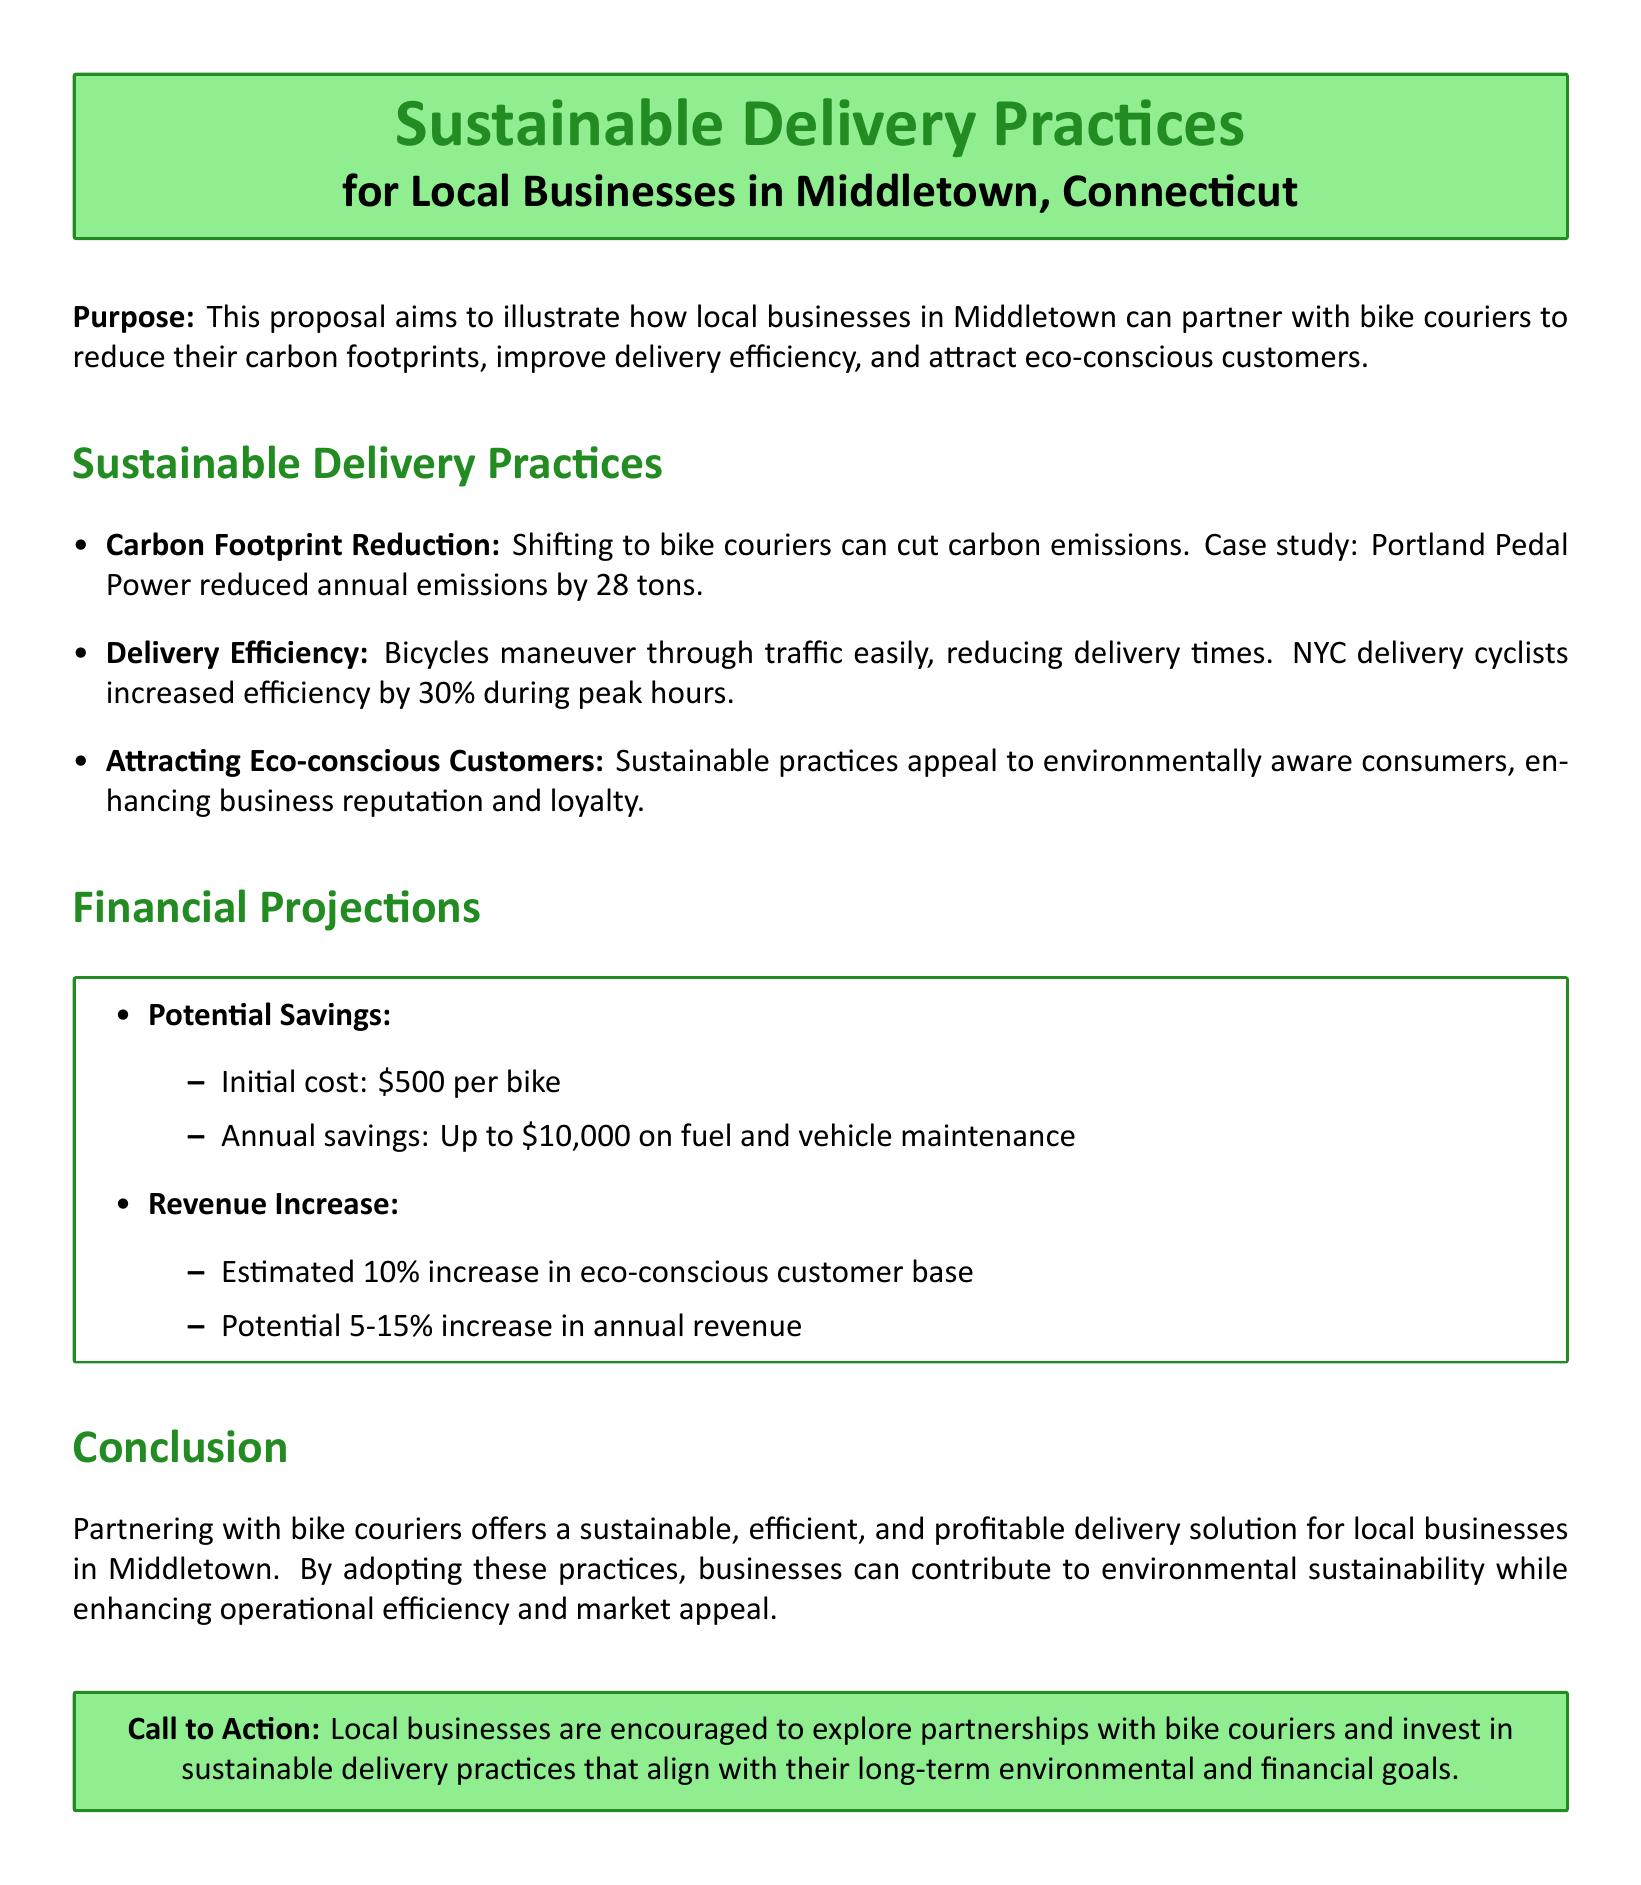What is the purpose of the proposal? The purpose of the proposal is to outline a strategy for local businesses to partner with bike couriers to promote sustainability and efficiency.
Answer: To reduce carbon footprints, improve delivery efficiency, and attract eco-conscious customers How many tons of emissions did Portland Pedal Power reduce? This is information related to the carbon footprint reduction case study mentioned in the document.
Answer: 28 tons What is the annual savings on fuel and maintenance? This information is provided under the potential savings section of the financial projections.
Answer: Up to $10,000 What percentage increase in delivery efficiency did NYC delivery cyclists achieve? This refers to the improvement in delivery times provided in the sustainable delivery practices.
Answer: 30% What is the initial cost per bike? This is a specific financial figure mentioned in the potential savings section of the financial projections.
Answer: $500 What is the estimated percentage increase in the eco-conscious customer base? This information can be found in the revenue increase section of the financial projections.
Answer: 10% What is the call to action for local businesses? This question refers to the encouragement provided at the end of the proposal regarding partnerships with bike couriers.
Answer: Explore partnerships with bike couriers 